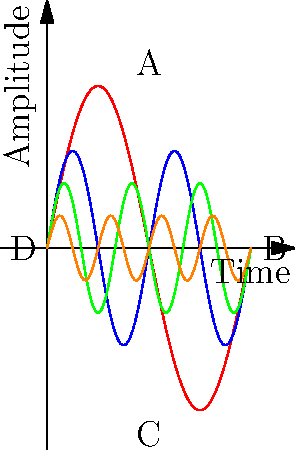Which EEG pattern is most likely to be observed in a patient taking a high dose of benzodiazepines, and how does this relate to the medication's mechanism of action? To answer this question, we need to consider the following steps:

1. Understand the effect of benzodiazepines on brain activity:
   Benzodiazepines enhance the effect of GABA (gamma-aminobutyric acid), the main inhibitory neurotransmitter in the brain.

2. Recognize the impact on EEG patterns:
   Benzodiazepines typically increase beta activity (13-30 Hz) and decrease alpha activity (8-13 Hz).

3. Analyze the given EEG patterns:
   A: High amplitude, low frequency (resembles delta waves, 0.5-4 Hz)
   B: Medium amplitude, medium frequency (resembles alpha waves, 8-13 Hz)
   C: Low amplitude, high frequency (resembles beta waves, 13-30 Hz)
   D: Very low amplitude, very high frequency (resembles gamma waves, >30 Hz)

4. Match the expected EEG changes with the observed patterns:
   The increase in beta activity and decrease in alpha activity caused by benzodiazepines most closely matches pattern C.

5. Relate to mechanism of action:
   The enhanced GABA activity leads to increased neuronal inhibition, resulting in faster, lower amplitude brain waves (beta activity).
Answer: Pattern C (beta waves), due to enhanced GABA activity 